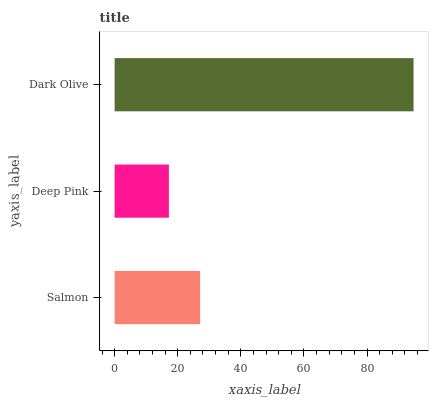Is Deep Pink the minimum?
Answer yes or no. Yes. Is Dark Olive the maximum?
Answer yes or no. Yes. Is Dark Olive the minimum?
Answer yes or no. No. Is Deep Pink the maximum?
Answer yes or no. No. Is Dark Olive greater than Deep Pink?
Answer yes or no. Yes. Is Deep Pink less than Dark Olive?
Answer yes or no. Yes. Is Deep Pink greater than Dark Olive?
Answer yes or no. No. Is Dark Olive less than Deep Pink?
Answer yes or no. No. Is Salmon the high median?
Answer yes or no. Yes. Is Salmon the low median?
Answer yes or no. Yes. Is Dark Olive the high median?
Answer yes or no. No. Is Deep Pink the low median?
Answer yes or no. No. 